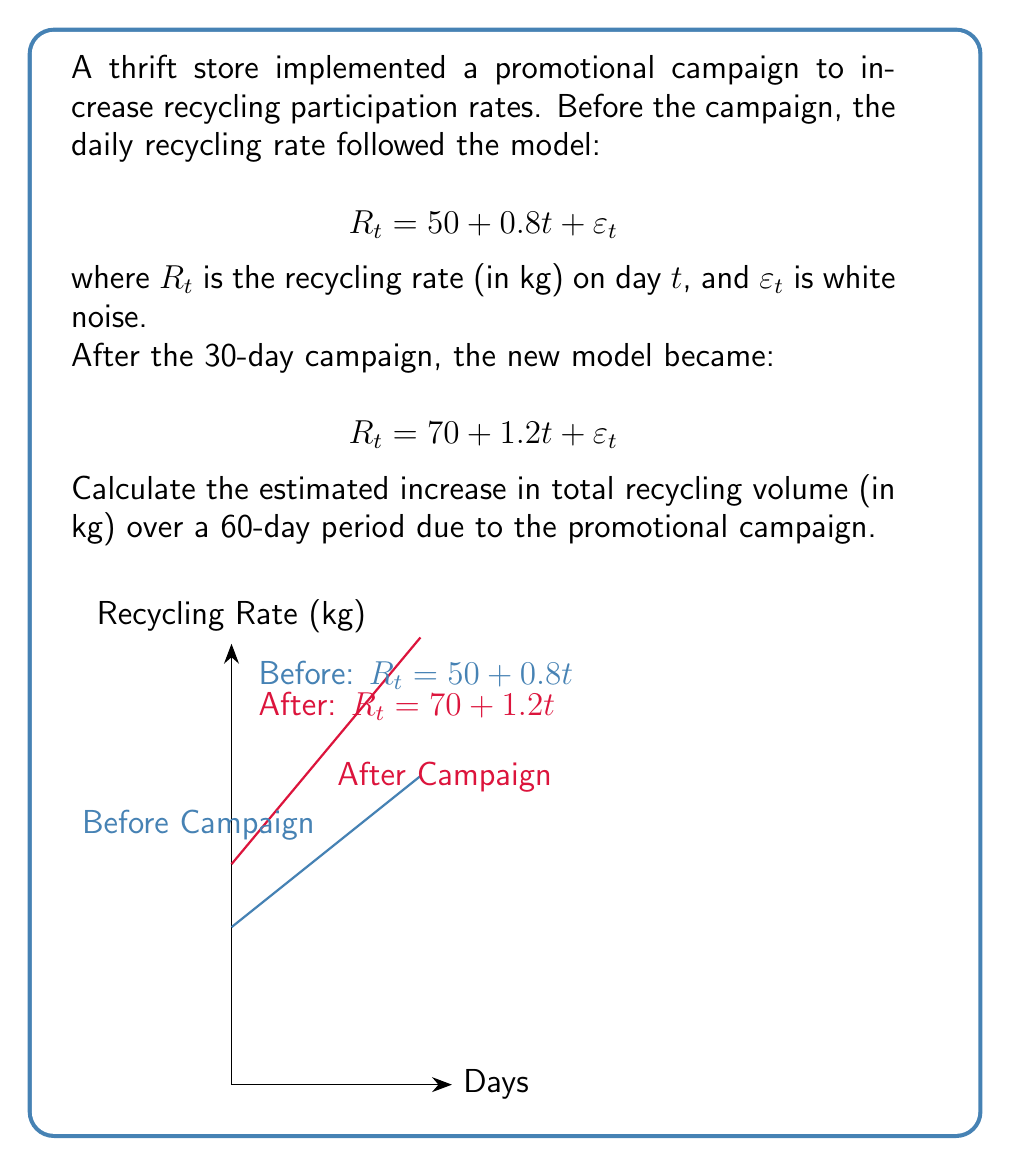What is the answer to this math problem? Let's approach this step-by-step:

1) We need to calculate the total recycling volume for both scenarios (before and after the campaign) over 60 days, then find the difference.

2) For the period before the campaign:
   $$R_t = 50 + 0.8t$$
   Total volume = $\sum_{t=1}^{60} (50 + 0.8t)$

3) For arithmetic sequences, we can use the formula:
   $S_n = \frac{n}{2}(a_1 + a_n)$, where $a_1$ is the first term and $a_n$ is the last term.

4) First term (t=1): $50 + 0.8(1) = 50.8$
   Last term (t=60): $50 + 0.8(60) = 98$

5) Total volume before = $\frac{60}{2}(50.8 + 98) = 4,464$ kg

6) For the period after the campaign:
   $$R_t = 70 + 1.2t$$

7) First term (t=1): $70 + 1.2(1) = 71.2$
   Last term (t=60): $70 + 1.2(60) = 142$

8) Total volume after = $\frac{60}{2}(71.2 + 142) = 6,396$ kg

9) The increase in total recycling volume:
   $6,396 - 4,464 = 1,932$ kg
Answer: 1,932 kg 